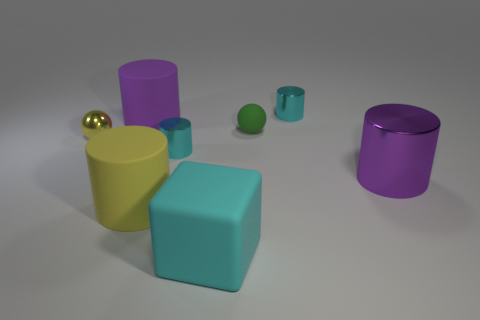Is there any other thing that has the same size as the green thing?
Your response must be concise. Yes. Does the yellow matte thing have the same shape as the purple shiny object?
Provide a short and direct response. Yes. Are there fewer small cylinders in front of the green matte sphere than small cylinders to the left of the big purple rubber cylinder?
Give a very brief answer. No. What number of yellow matte things are on the right side of the purple rubber thing?
Your answer should be very brief. 1. There is a small cyan shiny thing that is behind the small matte object; is its shape the same as the big object that is behind the purple metallic cylinder?
Offer a terse response. Yes. What number of other things are the same color as the small metal sphere?
Keep it short and to the point. 1. There is a purple cylinder on the left side of the cyan metal thing that is in front of the sphere that is on the right side of the big cyan matte cube; what is its material?
Offer a terse response. Rubber. There is a large object on the right side of the small shiny cylinder behind the yellow ball; what is it made of?
Give a very brief answer. Metal. Are there fewer small cylinders in front of the tiny yellow sphere than tiny yellow rubber cubes?
Your answer should be compact. No. There is a yellow object behind the yellow cylinder; what shape is it?
Offer a terse response. Sphere. 